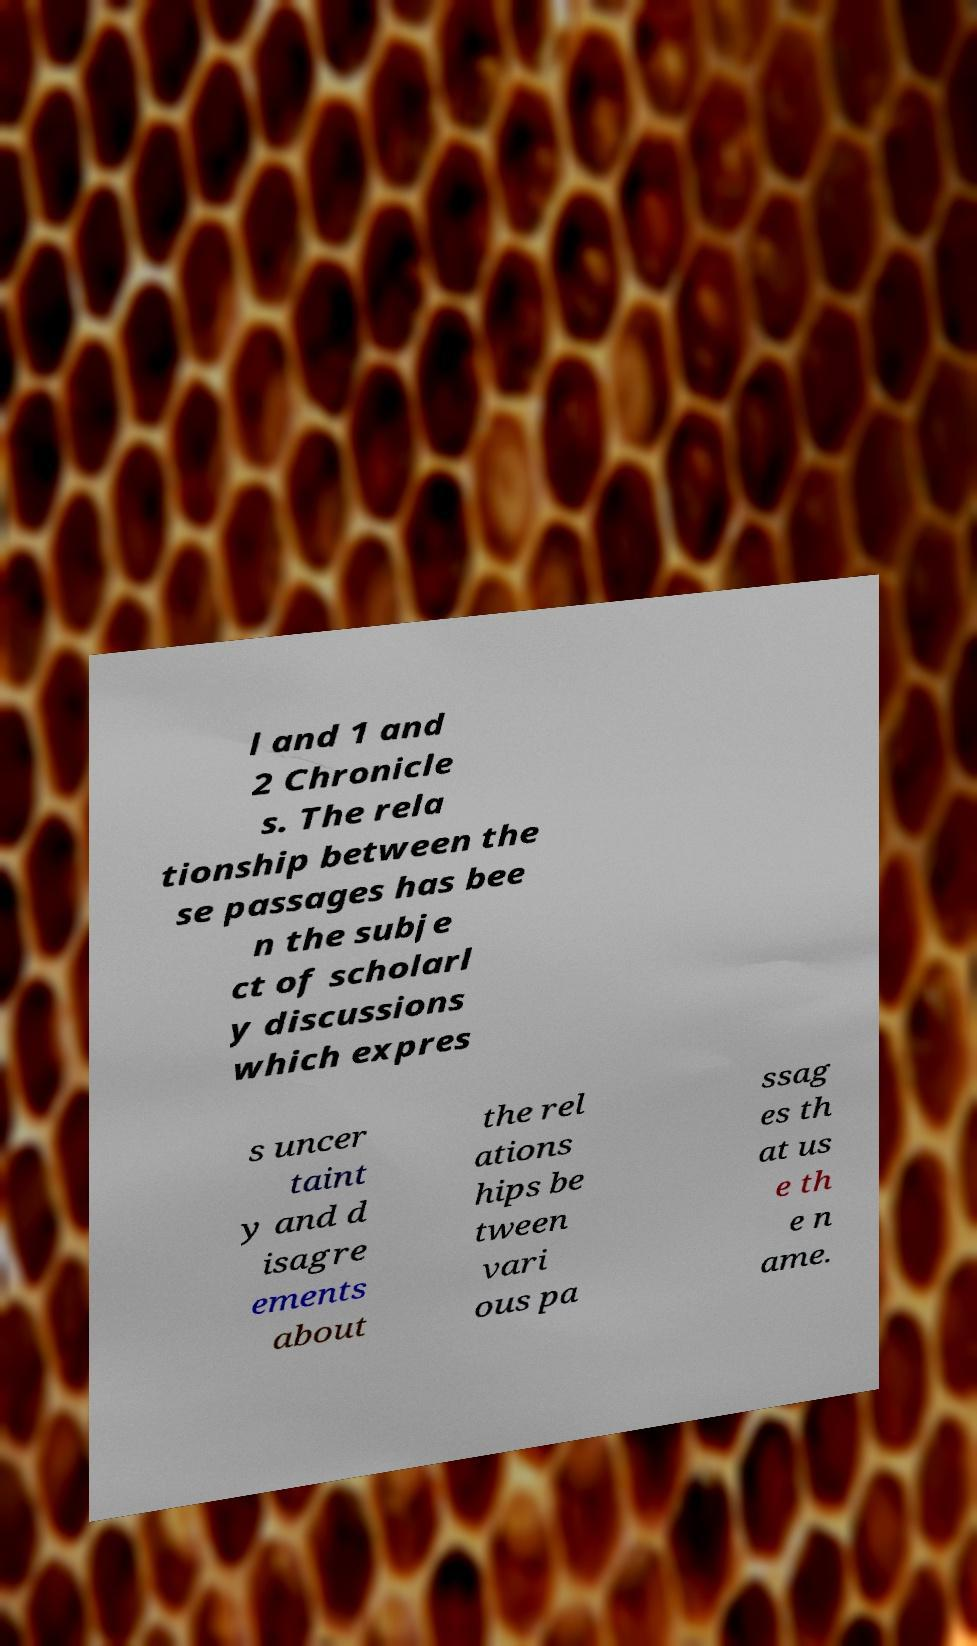Could you assist in decoding the text presented in this image and type it out clearly? l and 1 and 2 Chronicle s. The rela tionship between the se passages has bee n the subje ct of scholarl y discussions which expres s uncer taint y and d isagre ements about the rel ations hips be tween vari ous pa ssag es th at us e th e n ame. 